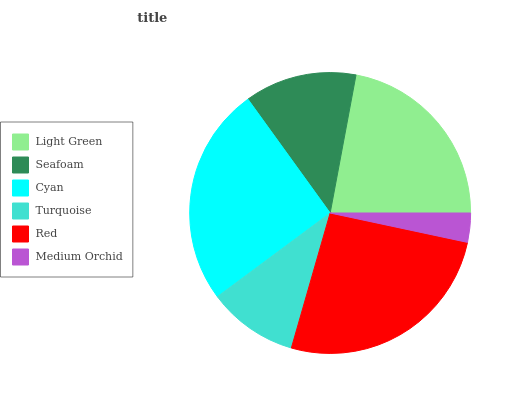Is Medium Orchid the minimum?
Answer yes or no. Yes. Is Red the maximum?
Answer yes or no. Yes. Is Seafoam the minimum?
Answer yes or no. No. Is Seafoam the maximum?
Answer yes or no. No. Is Light Green greater than Seafoam?
Answer yes or no. Yes. Is Seafoam less than Light Green?
Answer yes or no. Yes. Is Seafoam greater than Light Green?
Answer yes or no. No. Is Light Green less than Seafoam?
Answer yes or no. No. Is Light Green the high median?
Answer yes or no. Yes. Is Seafoam the low median?
Answer yes or no. Yes. Is Turquoise the high median?
Answer yes or no. No. Is Medium Orchid the low median?
Answer yes or no. No. 